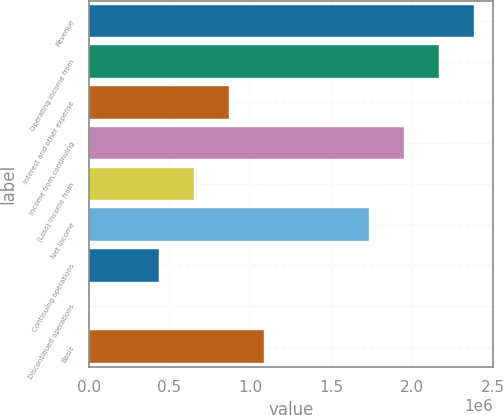Convert chart to OTSL. <chart><loc_0><loc_0><loc_500><loc_500><bar_chart><fcel>Revenue<fcel>Operating income from<fcel>Interest and other expense<fcel>Income from continuing<fcel>(Loss) income from<fcel>Net income<fcel>Continuing operations<fcel>Discontinued operations<fcel>Basic<nl><fcel>2.38286e+06<fcel>2.16623e+06<fcel>866493<fcel>1.94961e+06<fcel>649870<fcel>1.73299e+06<fcel>433246<fcel>0.01<fcel>1.08312e+06<nl></chart> 